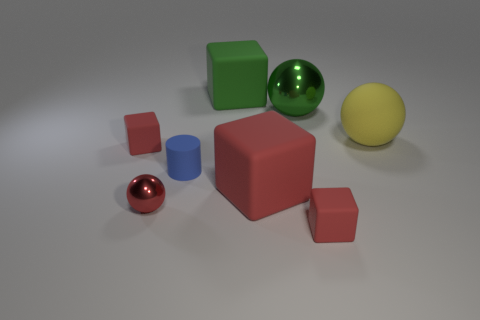What colors are the objects in the scene? The objects exhibit a variety of colors including red, green, blue, and yellow, as well as a couple of objects that appear to have a neutral color. 